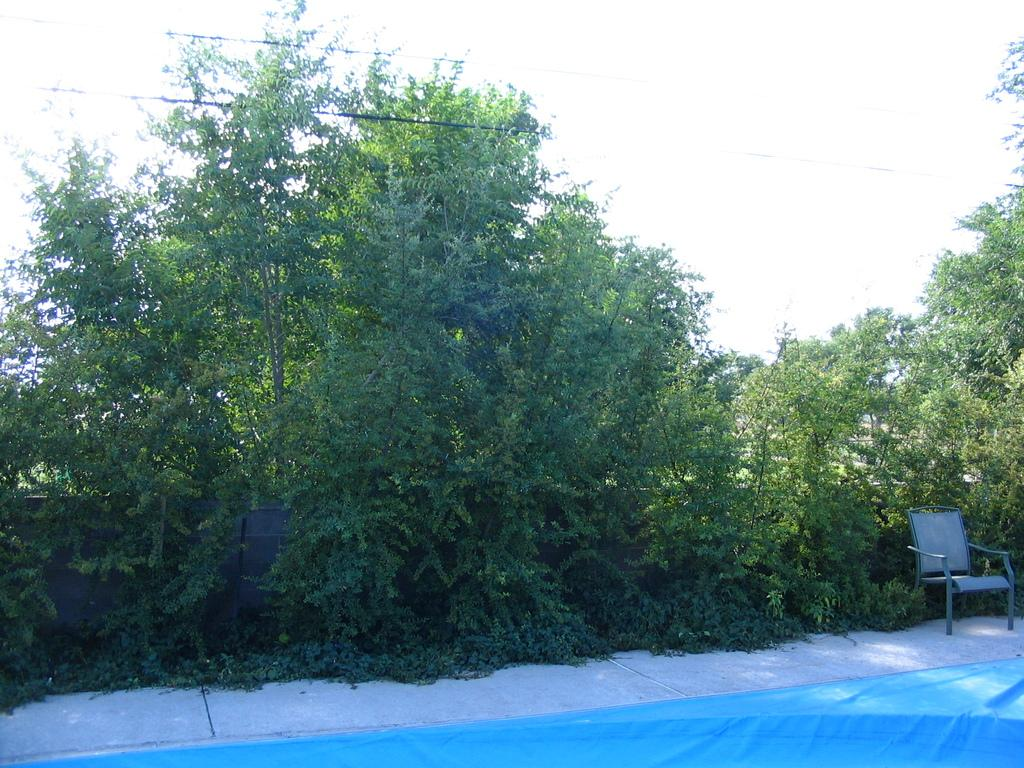What is located in the foreground of the image? There is an empty chair in the foreground of the image. What can be seen behind the chair? There are trees visible behind the chair. How do the waves affect the chair in the image? There are no waves present in the image, so they cannot affect the chair. 